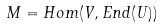Convert formula to latex. <formula><loc_0><loc_0><loc_500><loc_500>M = H o m ( V , E n d ( U ) )</formula> 